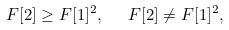Convert formula to latex. <formula><loc_0><loc_0><loc_500><loc_500>F [ 2 ] \geq F [ 1 ] ^ { 2 } , \ \ \ F [ 2 ] \ne F [ 1 ] ^ { 2 } ,</formula> 